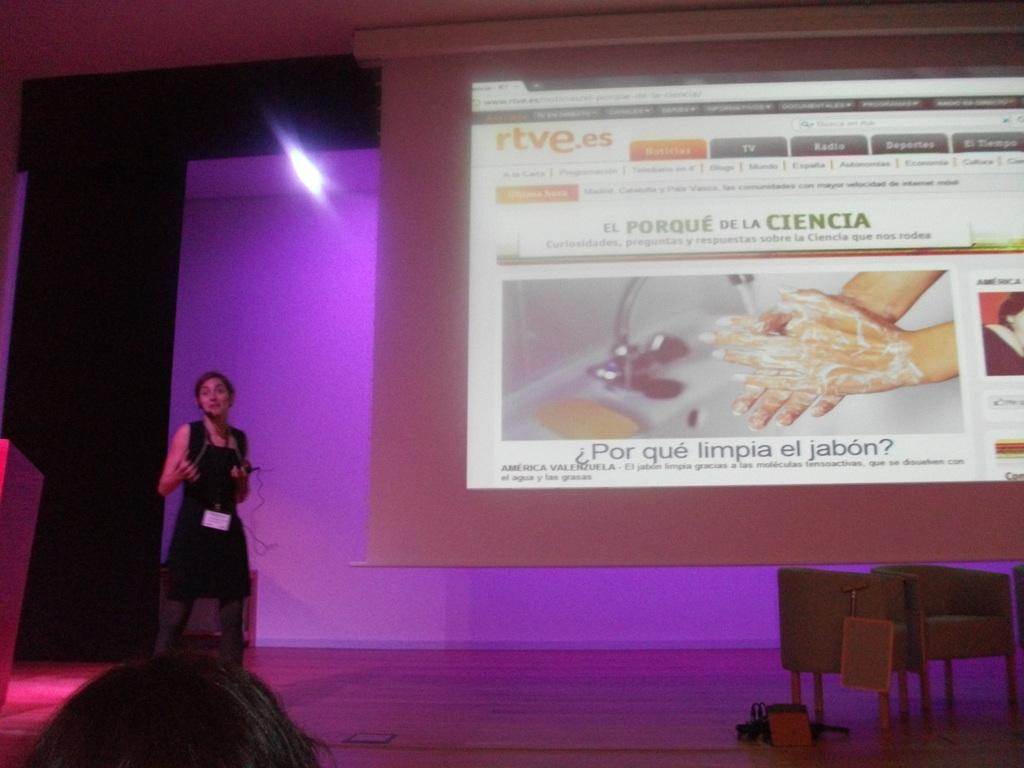What is the woman doing in the image? The woman is standing on the stage. What type of furniture is present in the image? There are chairs in the image. What is the purpose of the projector display screen in the image? The projector display screen is used for displaying visuals or presentations. What type of lettuce is being used as a prop by the woman on the stage? There is no lettuce present in the image, and the woman is not using any props. 